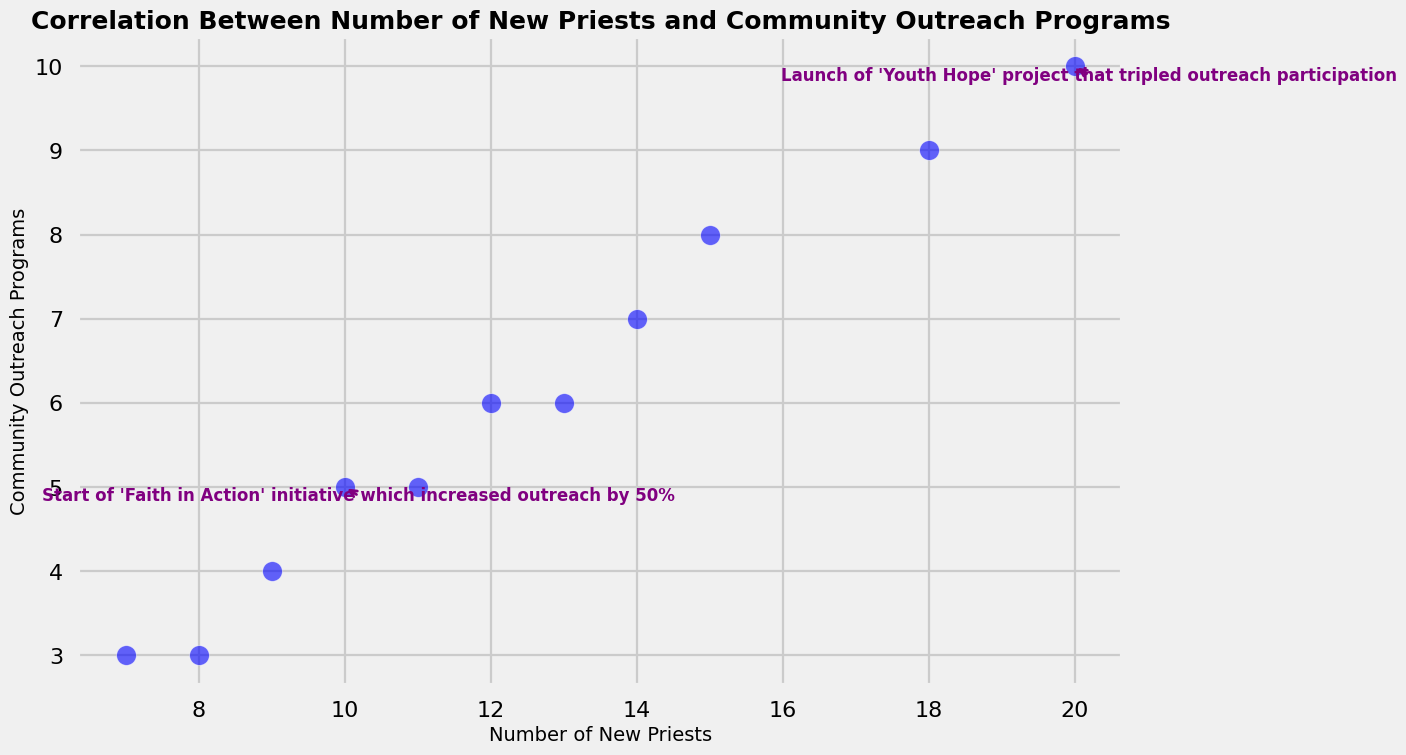Which data point corresponds to the launch of the 'Youth Hope' project? The annotation mentions the 'Youth Hope' project associated with a tripling of outreach participation. Locate the annotation text on the figure. It is positioned at the data point where the Number of New Priests is 20 and Community Outreach Programs is 10.
Answer: The point where Number of New Priests is 20 and Community Outreach Programs is 10 Does a higher number of new priests generally correlate with more community outreach programs? Observe the general trend in the scatter plot, where data points tend to rise diagonally from left to right, indicating a positive correlation between the number of new priests and community outreach programs.
Answer: Yes Which data point represents the start of the 'Faith in Action' initiative? The 'Faith in Action' initiative is annotated on the scatter plot. Look for the text annotation referencing this initiative. The annotation points to the data point where the Number of New Priests is 10 and Community Outreach Programs is 5.
Answer: The point where Number of New Priests is 10 and Community Outreach Programs is 5 Are there any data points where Community Outreach Programs remain the same despite an increase in the number of new priests? Compare each data point to see if there are instances where the Community Outreach Programs' value is identical despite the Number of New Priests increasing. The plot does not show any such instances.
Answer: No What is the total number of community outreach programs combined for data points with annotations? Identify the annotated data points and add up their Community Outreach Programs values: 5 (for 'Faith in Action') + 10 (for 'Youth Hope').
Answer: 15 Is there a data point where the number of new priests is less than or equal to 15, but the community outreach programs are higher than 7? Scan the scatter plot for data points fitting the criteria. The data point (Number of New Priests: 15, Community Outreach Programs: 8) satisfies these conditions.
Answer: Yes Which data point has the highest number of community outreach programs? Identify the highest y-value in the scatter plot, signifying the most community outreach programs. The highest data point is at (Number of New Priests: 20, Community Outreach Programs: 10).
Answer: The point where Number of New Priests is 20 and Community Outreach Programs is 10 What is the average number of community outreach programs for the plotted data? Sum up all the y-values (community outreach programs) and divide by the total number of points (10). (5+6+4+8+7+3+10+6+3+5+9)/11 = 66/11 = 6.
Answer: 6 